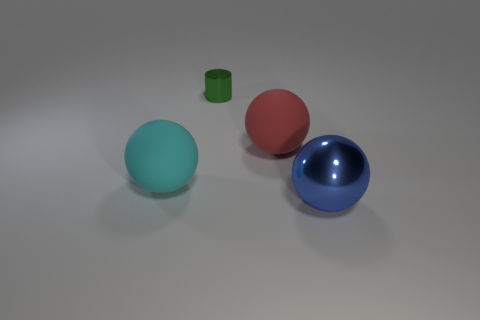Add 1 cyan matte spheres. How many objects exist? 5 Subtract all balls. How many objects are left? 1 Subtract 0 brown cubes. How many objects are left? 4 Subtract all large cyan rubber cubes. Subtract all blue metallic things. How many objects are left? 3 Add 1 blue objects. How many blue objects are left? 2 Add 3 large cyan balls. How many large cyan balls exist? 4 